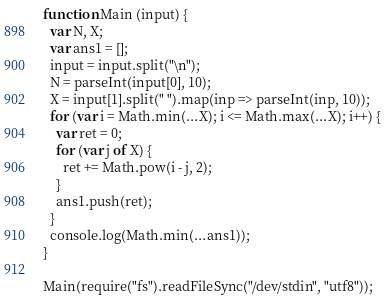<code> <loc_0><loc_0><loc_500><loc_500><_JavaScript_>function Main (input) {
  var N, X;
  var ans1 = [];
  input = input.split("\n");
  N = parseInt(input[0], 10);
  X = input[1].split(" ").map(inp => parseInt(inp, 10));
  for (var i = Math.min(...X); i <= Math.max(...X); i++) {
    var ret = 0;
    for (var j of X) {
      ret += Math.pow(i - j, 2);
    }
    ans1.push(ret);
  }
  console.log(Math.min(...ans1));
}

Main(require("fs").readFileSync("/dev/stdin", "utf8"));</code> 